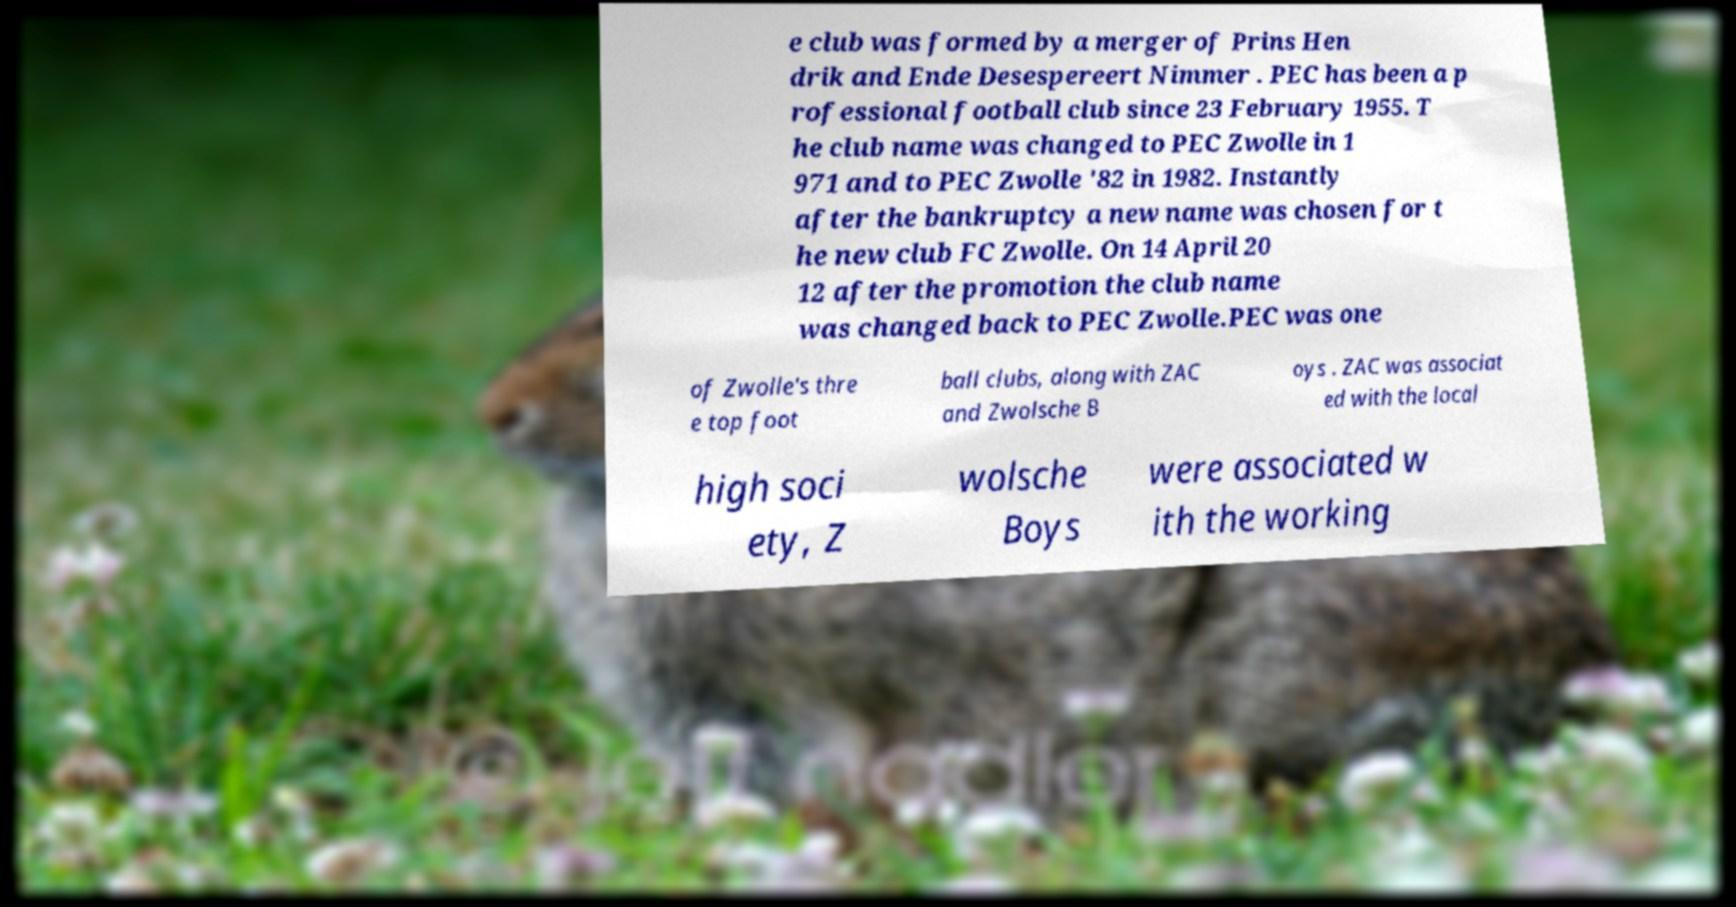I need the written content from this picture converted into text. Can you do that? e club was formed by a merger of Prins Hen drik and Ende Desespereert Nimmer . PEC has been a p rofessional football club since 23 February 1955. T he club name was changed to PEC Zwolle in 1 971 and to PEC Zwolle '82 in 1982. Instantly after the bankruptcy a new name was chosen for t he new club FC Zwolle. On 14 April 20 12 after the promotion the club name was changed back to PEC Zwolle.PEC was one of Zwolle's thre e top foot ball clubs, along with ZAC and Zwolsche B oys . ZAC was associat ed with the local high soci ety, Z wolsche Boys were associated w ith the working 